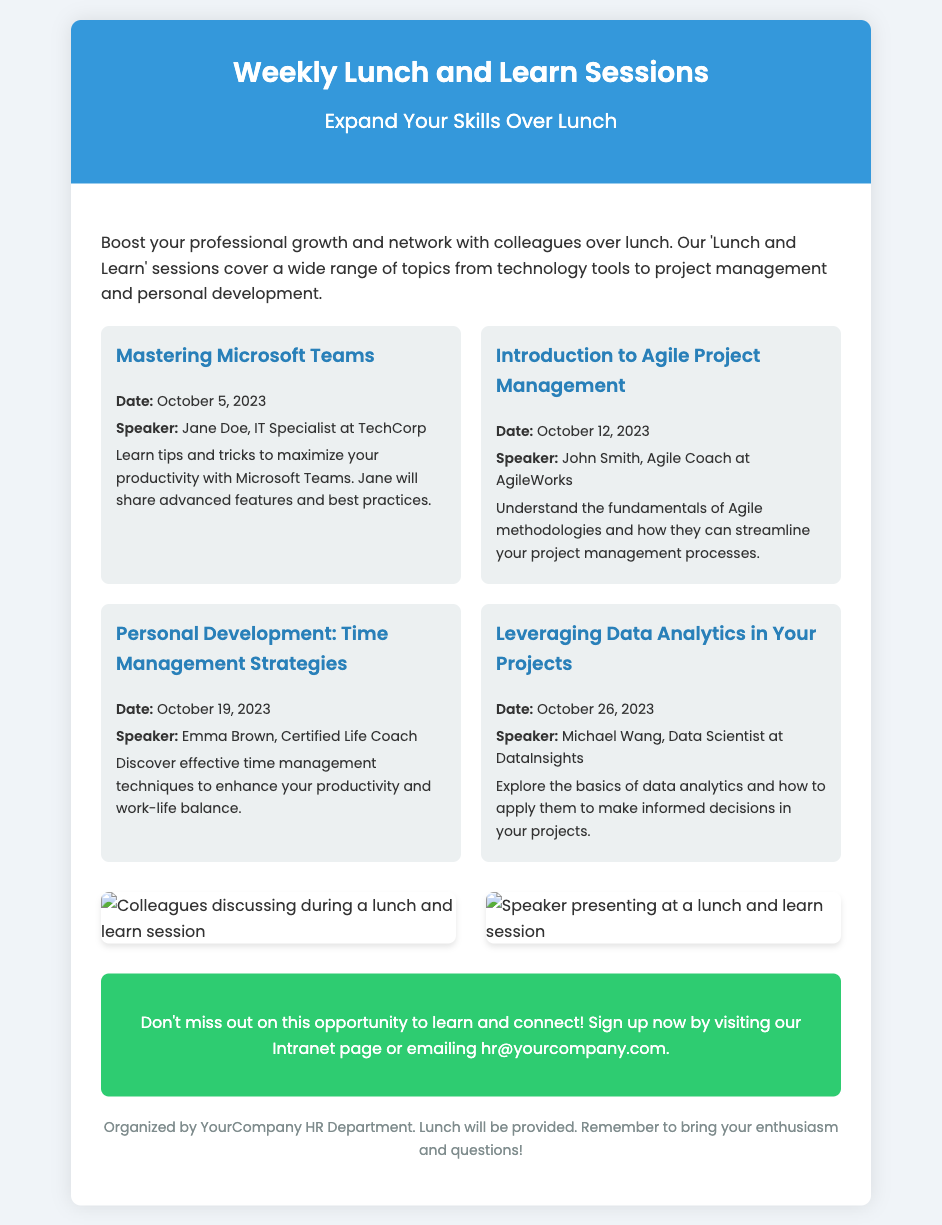What is the first session topic? The first session listed in the schedule covers tips and tricks for using Microsoft Teams.
Answer: Mastering Microsoft Teams Who is the speaker for the session on October 12, 2023? This session focuses on Agile Project Management and is conducted by John Smith.
Answer: John Smith When is the session on Time Management Strategies scheduled? The session on Time Management Strategies is listed for October 19, 2023.
Answer: October 19, 2023 What is the main focus of the session on October 26, 2023? The session discusses how to apply data analytics to projects.
Answer: Leveraging Data Analytics in Your Projects How many sessions are outlined in the document? The document lists a total of four unique 'Lunch and Learn' sessions.
Answer: Four What is included in the call-to-action section? The call-to-action encourages participants to sign up via the Intranet page or email HR.
Answer: Sign up now by visiting our Intranet page or emailing hr@yourcompany.com What background color is used for the header? The header features a vibrant blue background color.
Answer: #3498db Which department is organizing the Lunch and Learn sessions? The sessions are organized by the HR Department of the company.
Answer: HR Department 